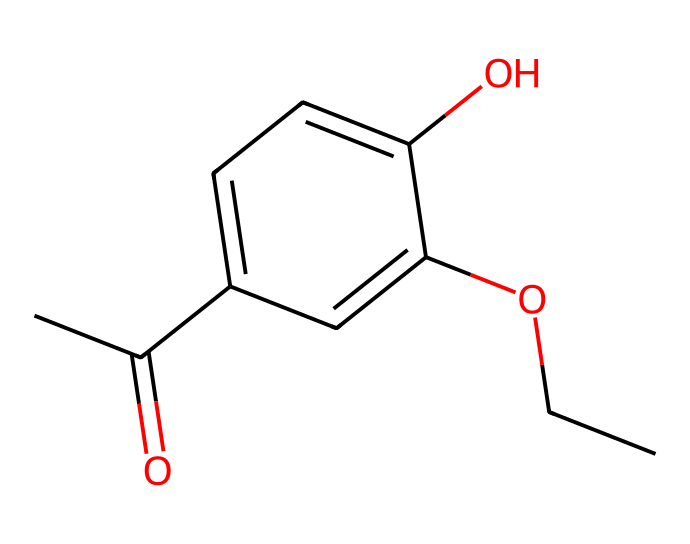What is the molecular formula of this chemical? By analyzing the SMILES representation, we can count all the atoms: there are 11 carbon (C), 12 hydrogen (H), and 3 oxygen (O) atoms in total, leading to the molecular formula C11H12O3.
Answer: C11H12O3 How many hydroxyl (–OH) groups are present in this structure? The structure shows two distinct –OH groups, identifiable by the oxygen atom bonded to a hydrogen atom. Each –OH group appears in the molecular structure as a hydroxyl functional group.
Answer: 2 What type of functional groups are present in this chemical? The primary functional groups in the SMILES representation are hydroxyl (–OH) groups and a carbonyl (C=O) group from the acetyl (–COCH3) moiety. These functional groups define the chemical's reactivity and properties.
Answer: hydroxyl and carbonyl Which part of this chemical contributes to its potential aromas? The aromatic ring (the benzene structure) contributes significantly to the fragrance properties due to its resonance stabilization and ability to interact with olfactory receptors; this is indicative of aromatic compounds often used in perfumes.
Answer: aromatic ring What kind of chemical is represented by this structure? This chemical is an aromatic compound, specifically a substituted phenol, which is common in the formulation of synthetic fragrances because of its pleasant odor and ability to modify scent profiles.
Answer: aromatic compound 